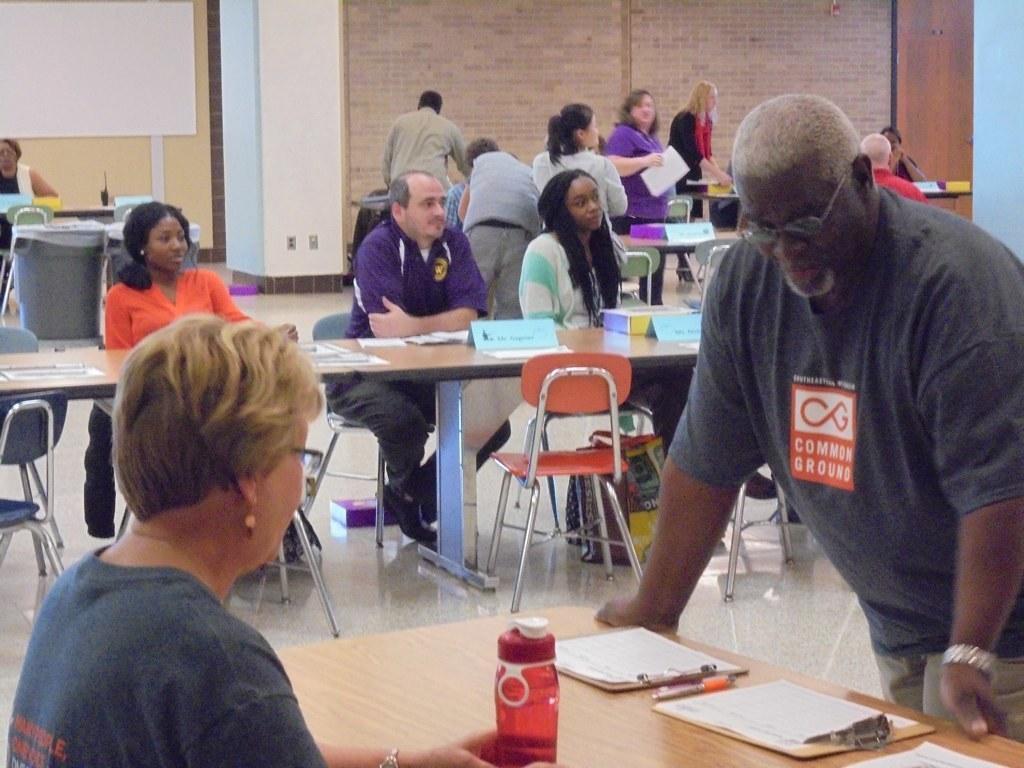Describe this image in one or two sentences. In the image we can see there is a person who is standing here and on table there is paper with pad, pen and red colour water bottle. There is woman who is sitting here and there are three people who are sitting on chair and on table there are papers, name plate and box. At the back few people are standing. 